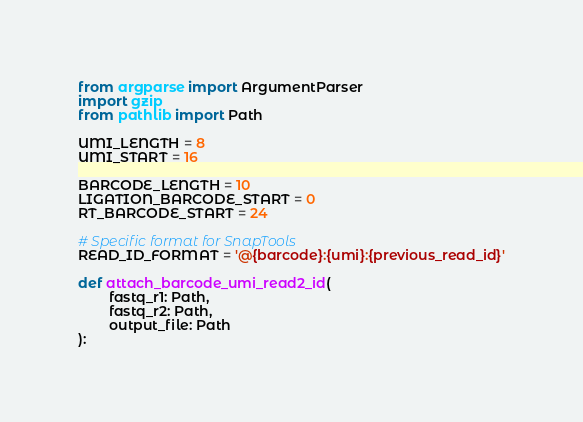<code> <loc_0><loc_0><loc_500><loc_500><_Python_>from argparse import ArgumentParser
import gzip
from pathlib import Path

UMI_LENGTH = 8
UMI_START = 16

BARCODE_LENGTH = 10
LIGATION_BARCODE_START = 0
RT_BARCODE_START = 24

# Specific format for SnapTools
READ_ID_FORMAT = '@{barcode}:{umi}:{previous_read_id}'

def attach_barcode_umi_read2_id(
        fastq_r1: Path,
        fastq_r2: Path,
        output_file: Path
):</code> 